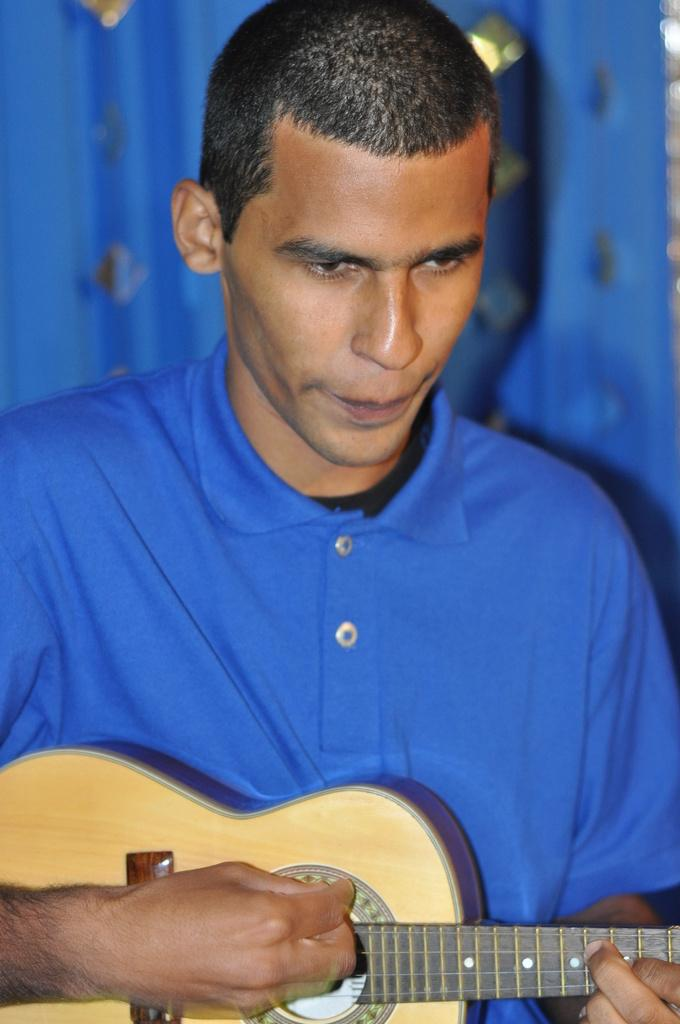What is present in the image? There is a man in the image. Can you describe what the man is wearing? The man is wearing a blue t-shirt. What is the man holding in his hands? The man is holding a guitar in his hands. What place is depicted in the image? The image does not depict a specific place; it only shows a man holding a guitar. Is there a zipper visible on the man's clothing in the image? There is no zipper visible on the man's clothing in the image, as he is wearing a t-shirt. What is the man doing to the earth in the image? The image does not show the man doing anything to the earth; it only shows him holding a guitar. 